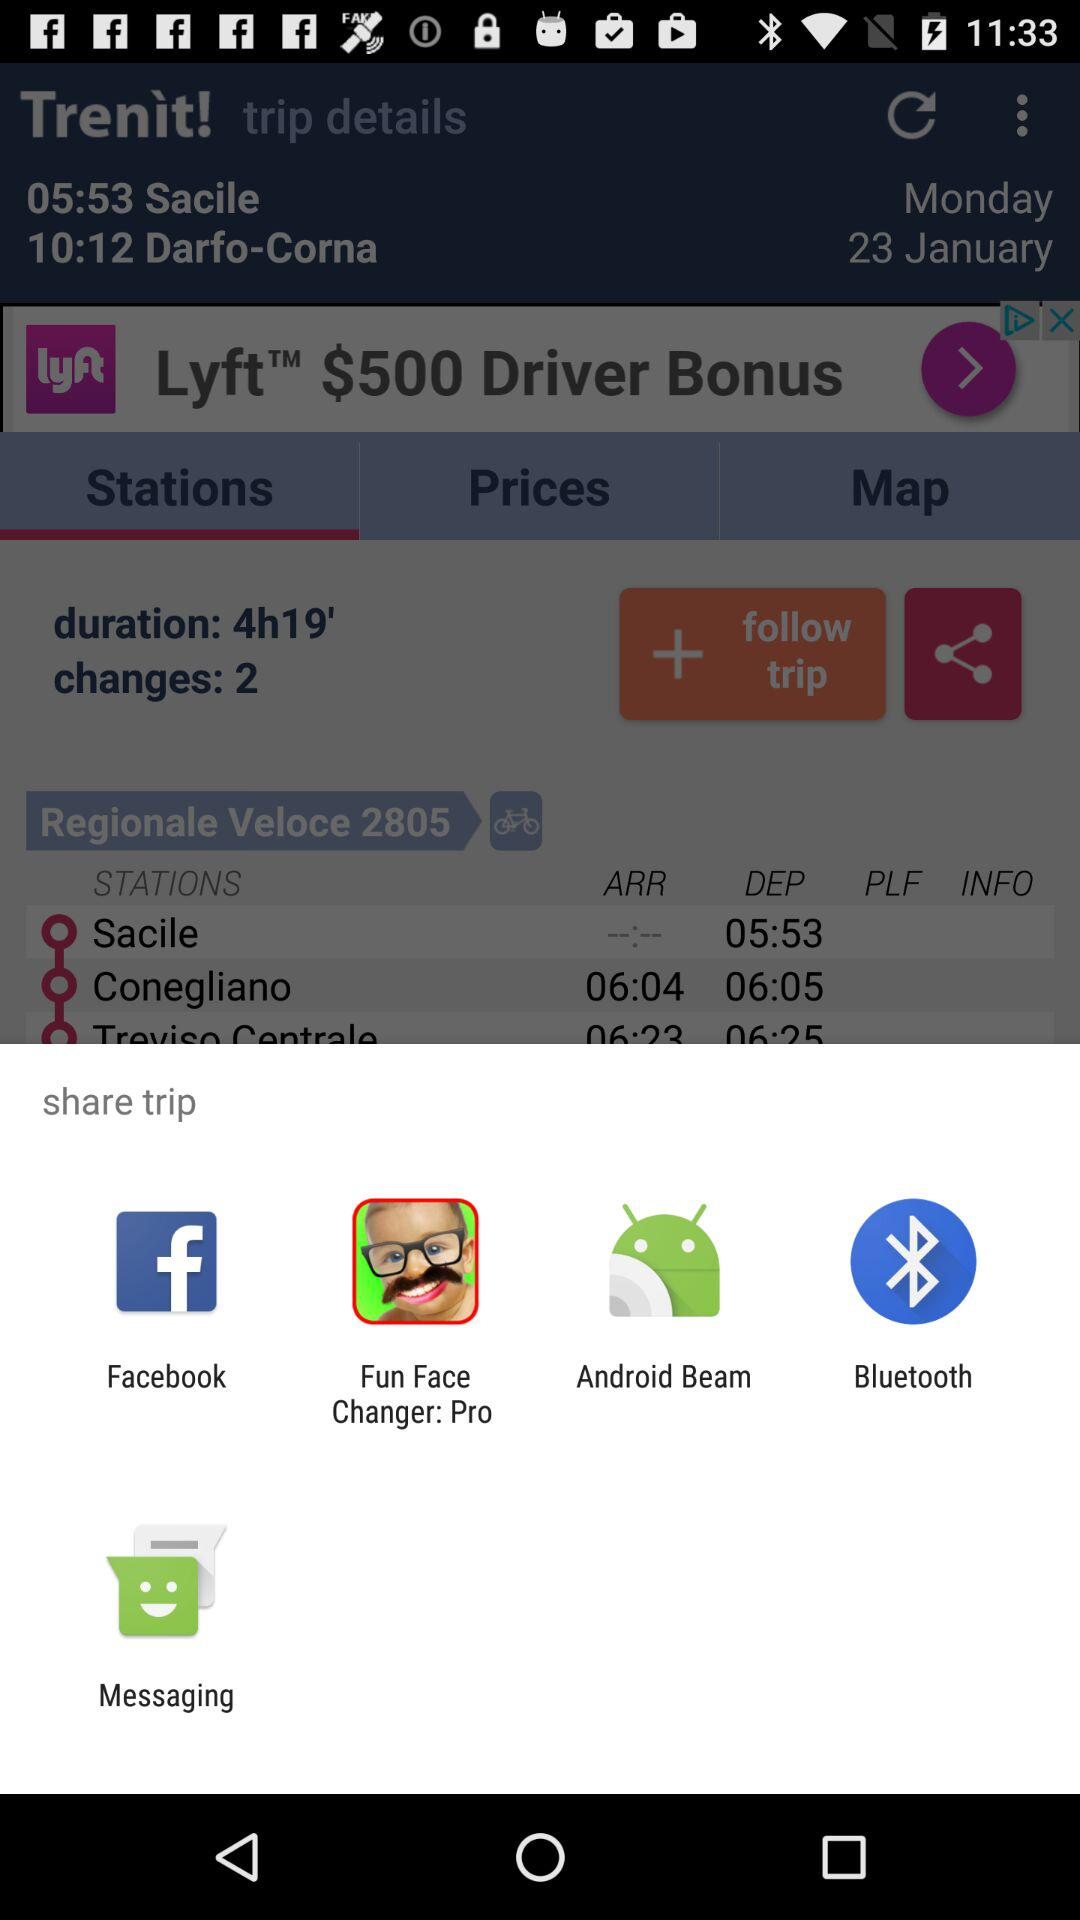How many hours long is the trip?
Answer the question using a single word or phrase. 4h19' 